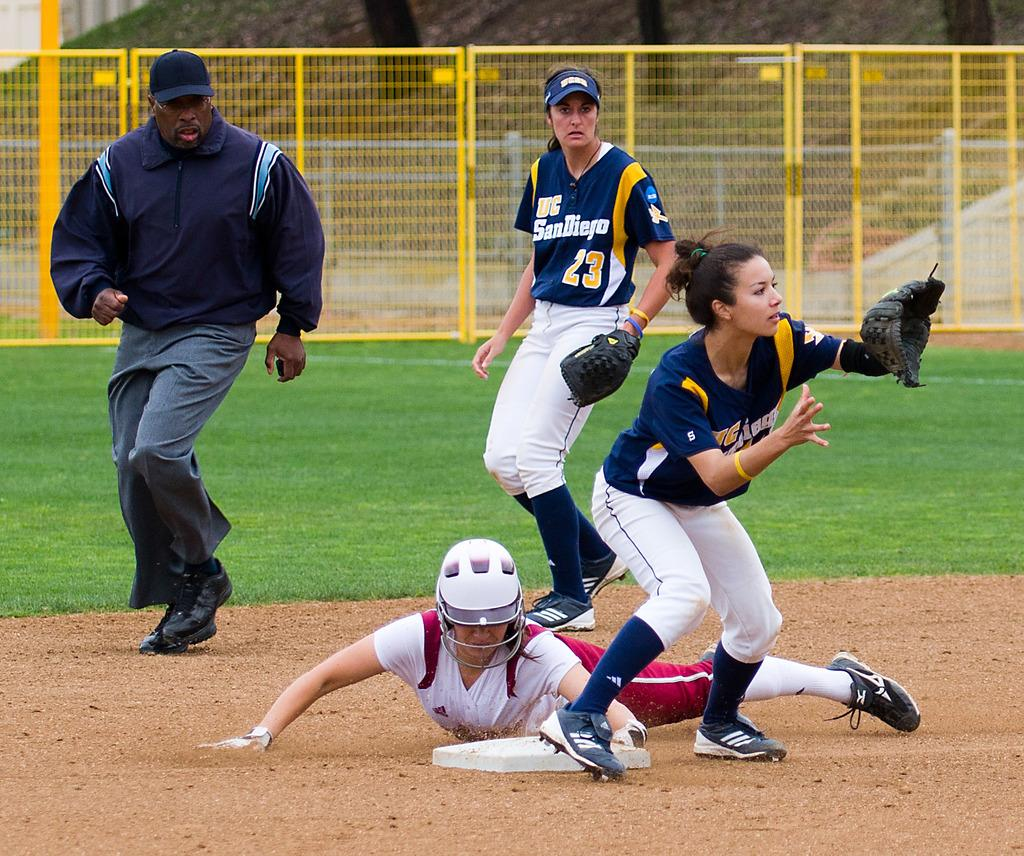<image>
Share a concise interpretation of the image provided. A UC San Diego ball player is poised to make a catch. 